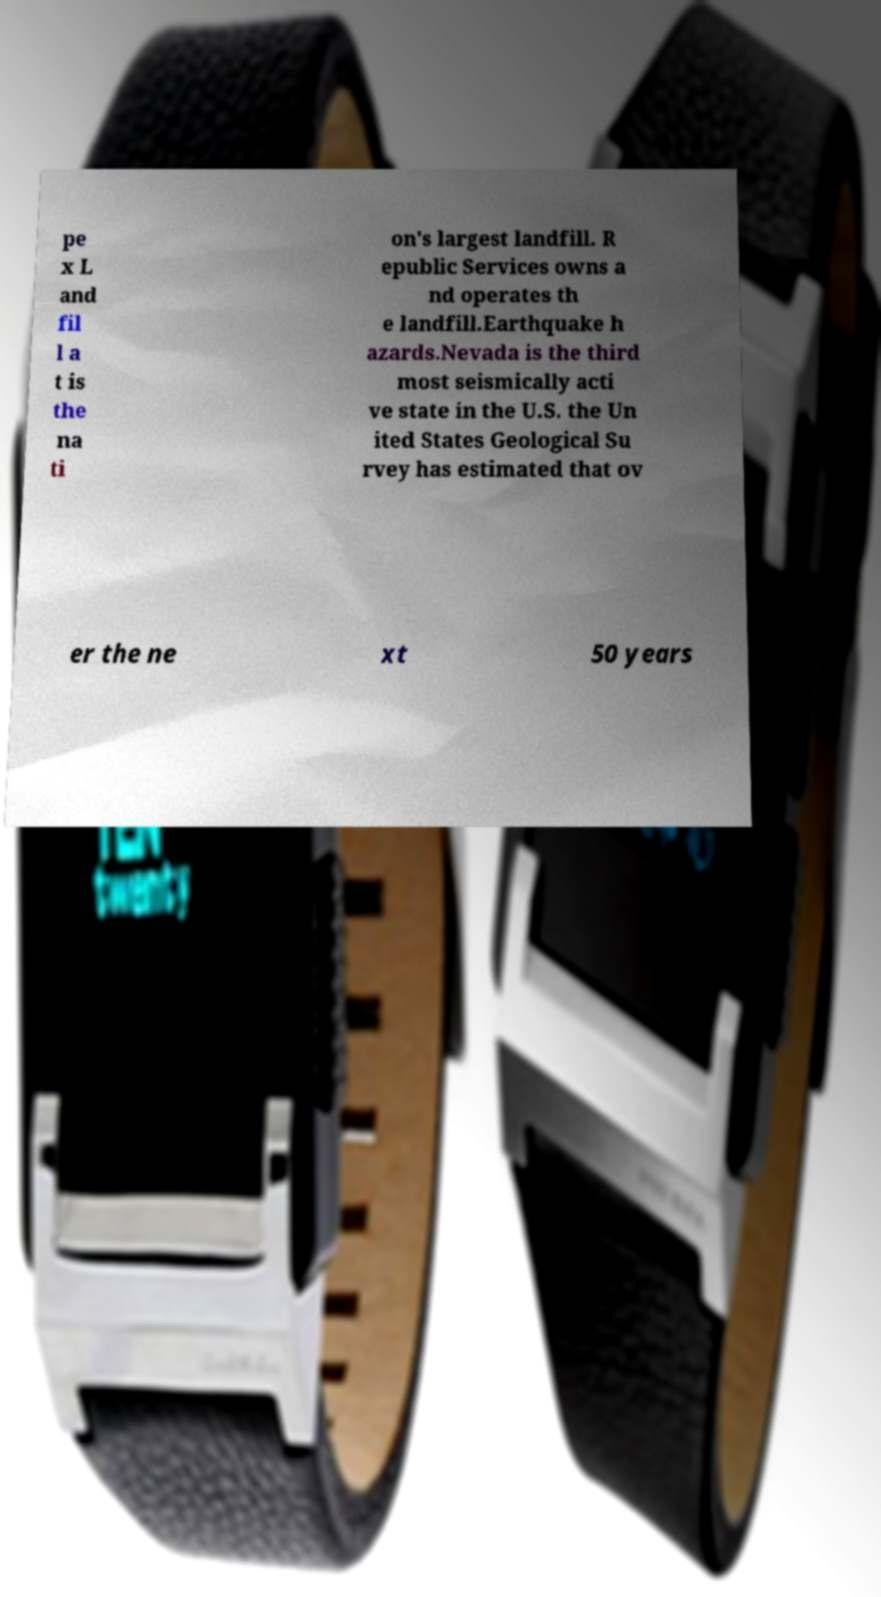Can you accurately transcribe the text from the provided image for me? pe x L and fil l a t is the na ti on's largest landfill. R epublic Services owns a nd operates th e landfill.Earthquake h azards.Nevada is the third most seismically acti ve state in the U.S. the Un ited States Geological Su rvey has estimated that ov er the ne xt 50 years 